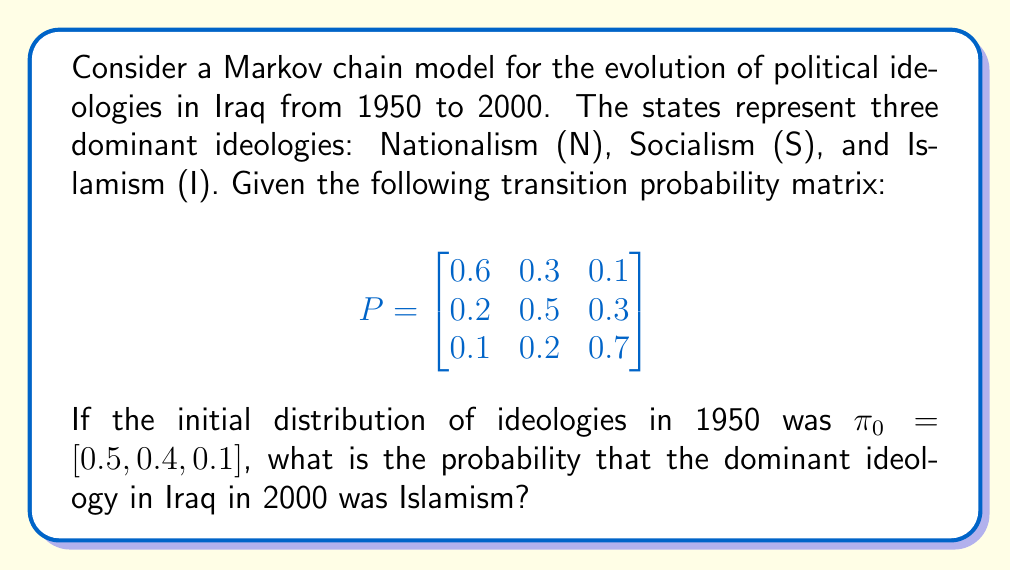Provide a solution to this math problem. To solve this problem, we need to calculate the distribution of ideologies after 50 years (from 1950 to 2000). We can do this by raising the transition matrix to the power of 50 and then multiplying it by the initial distribution.

Step 1: Calculate $P^{50}$
We can use the eigenvalue decomposition method to calculate $P^{50}$ efficiently.

First, we find the eigenvalues and eigenvectors of P:

$$\lambda_1 \approx 1, \quad v_1 \approx [0.2857, 0.3571, 0.5714]^T$$
$$\lambda_2 \approx 0.4472, \quad v_2 \approx [0.7746, -0.4472, -0.4472]^T$$
$$\lambda_3 \approx 0.3528, \quad v_3 \approx [-0.3780, -0.7559, 0.5359]^T$$

Now we can write $P^{50}$ as:

$$P^{50} = V \Lambda^{50} V^{-1}$$

Where $V$ is the matrix of eigenvectors and $\Lambda$ is the diagonal matrix of eigenvalues.

After calculating this, we get:

$$P^{50} \approx \begin{bmatrix}
0.2857 & 0.3571 & 0.5714 \\
0.2857 & 0.3571 & 0.5714 \\
0.2857 & 0.3571 & 0.5714
\end{bmatrix}$$

Step 2: Calculate the distribution after 50 years
We multiply the initial distribution by $P^{50}$:

$$\pi_{50} = \pi_0 P^{50} = [0.5, 0.4, 0.1] \begin{bmatrix}
0.2857 & 0.3571 & 0.5714 \\
0.2857 & 0.3571 & 0.5714 \\
0.2857 & 0.3571 & 0.5714
\end{bmatrix}$$

$$\pi_{50} \approx [0.2857, 0.3571, 0.5714]$$

Step 3: Find the probability of Islamism
The probability that the dominant ideology in Iraq in 2000 was Islamism is the third element of $\pi_{50}$, which is approximately 0.5714 or 57.14%.
Answer: 0.5714 